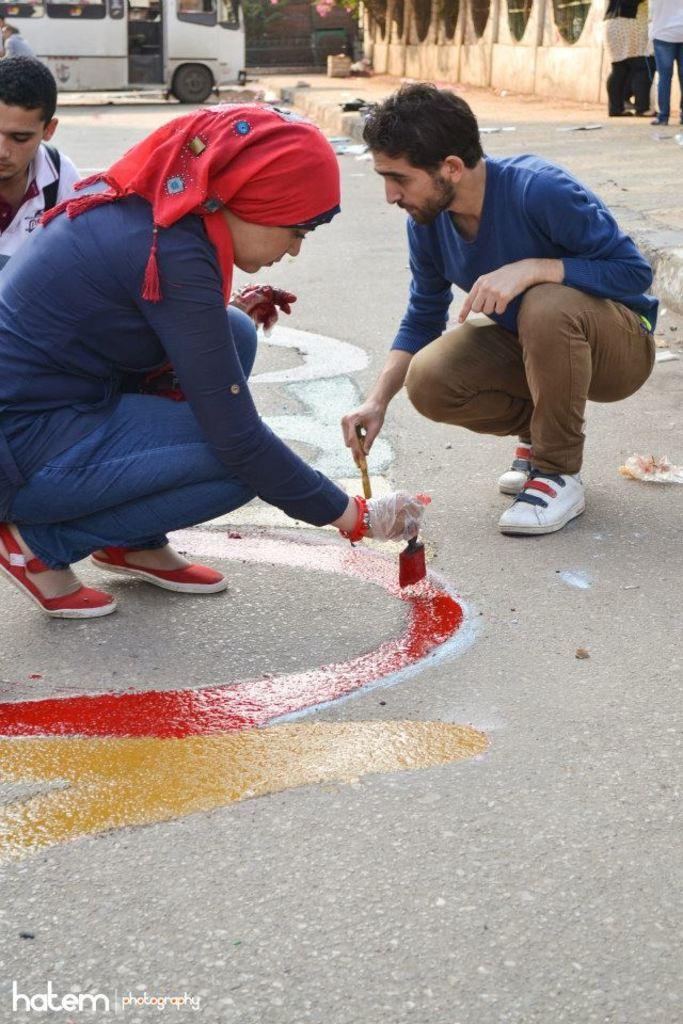Can you describe this image briefly? In this image, we can see three people are on the road. Few are painting a color. Top of the image, there is a vehicle, wall, few plants, some objects. Here we can see few people are standing on the footpath. At the bottom of the image, there is a watermark in the image. 